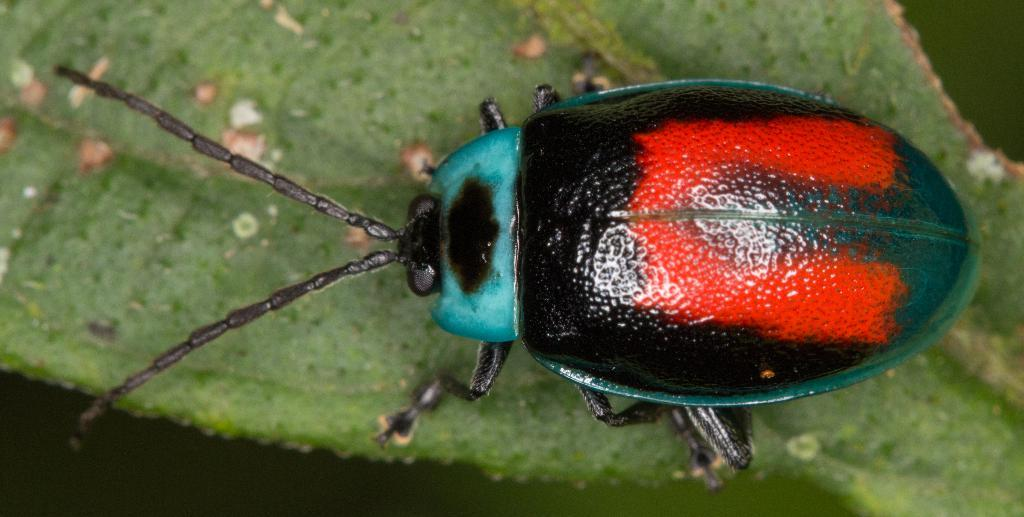What type of insect is present in the image? There is a flower beetle in the image. Where is the flower beetle located? The flower beetle is on a leaf. What type of activity is the flower beetle participating in with the other insects in the image? There are no other insects present in the image, and the flower beetle is not participating in any activity with them. 